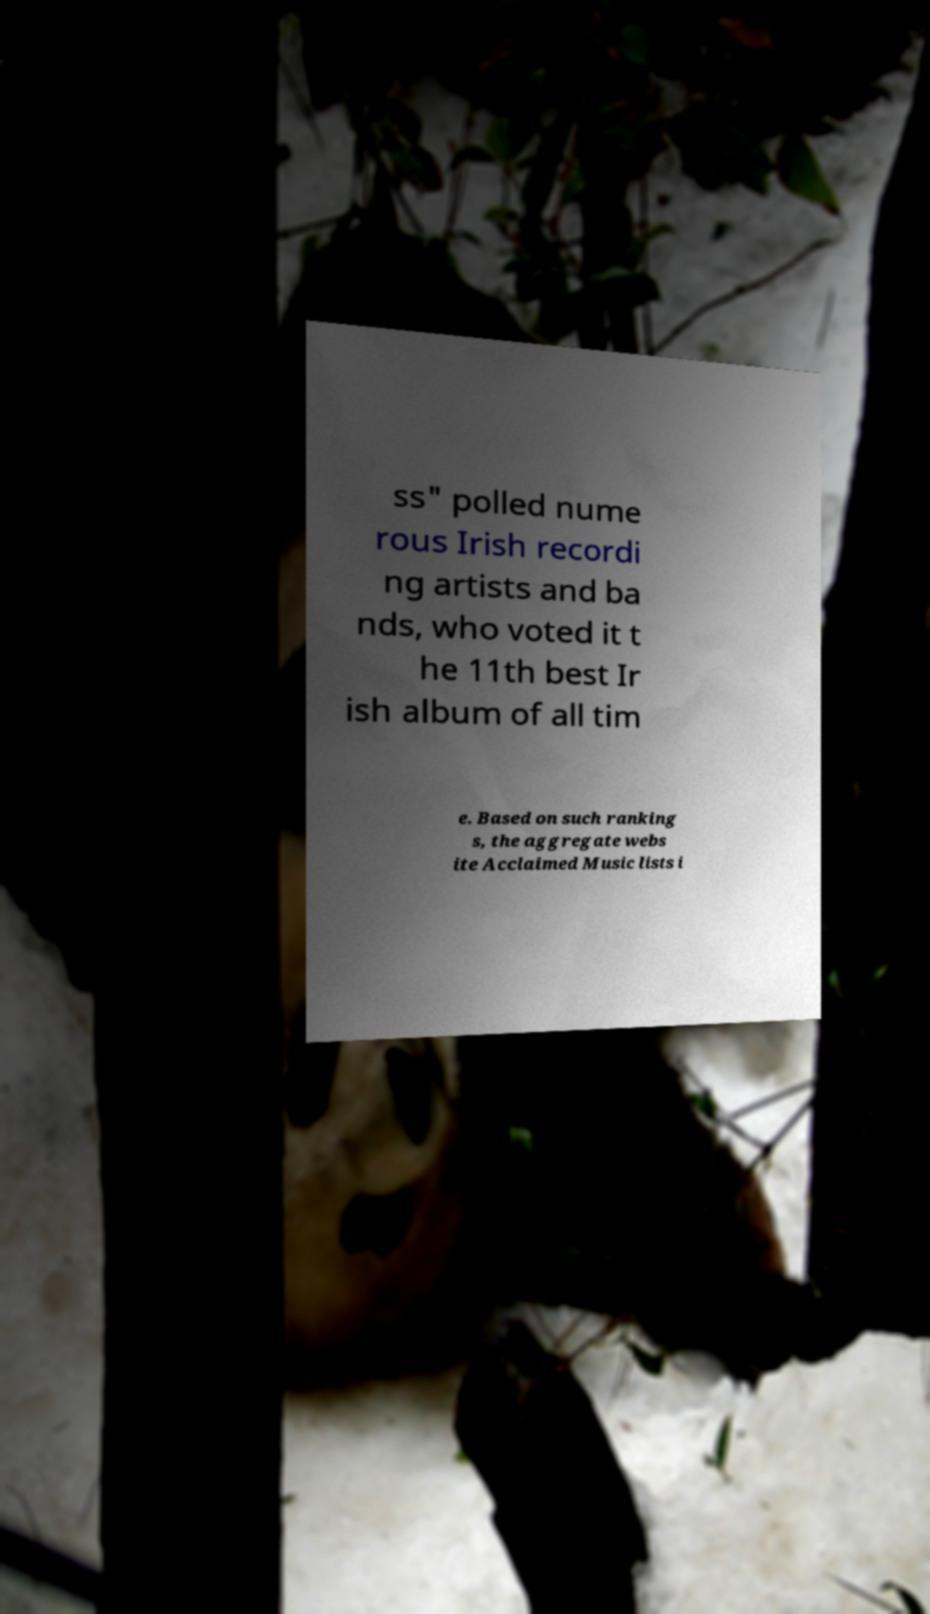Could you extract and type out the text from this image? ss" polled nume rous Irish recordi ng artists and ba nds, who voted it t he 11th best Ir ish album of all tim e. Based on such ranking s, the aggregate webs ite Acclaimed Music lists i 